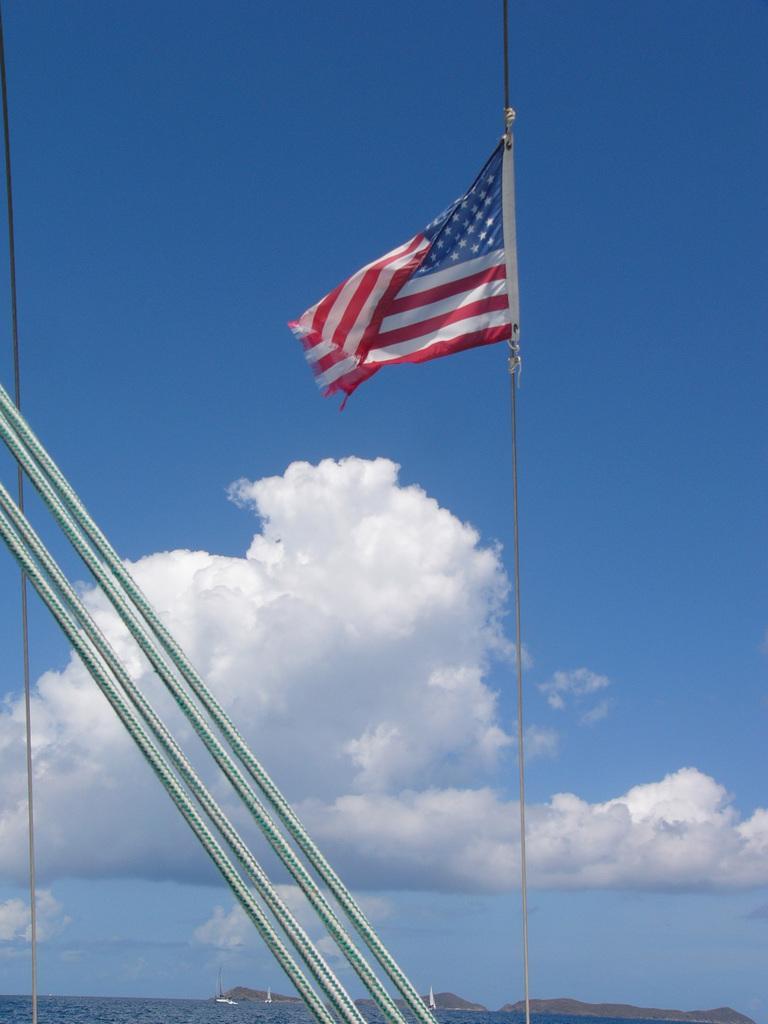How would you summarize this image in a sentence or two? In this image, we can see poles, ropes and a flag. At the bottom, there is water and at the top, there are clouds in the sky. 